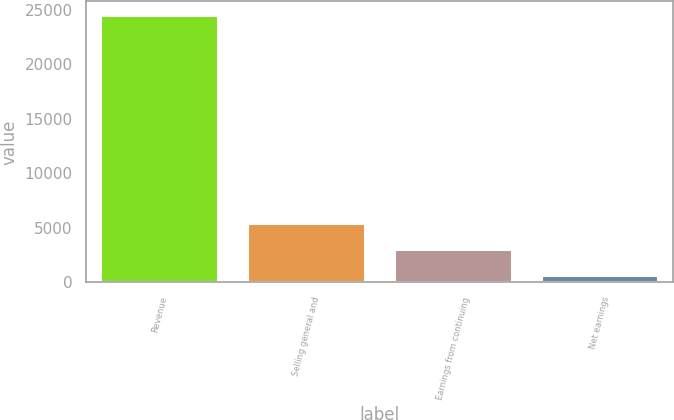<chart> <loc_0><loc_0><loc_500><loc_500><bar_chart><fcel>Revenue<fcel>Selling general and<fcel>Earnings from continuing<fcel>Net earnings<nl><fcel>24548<fcel>5473.6<fcel>3089.3<fcel>705<nl></chart> 